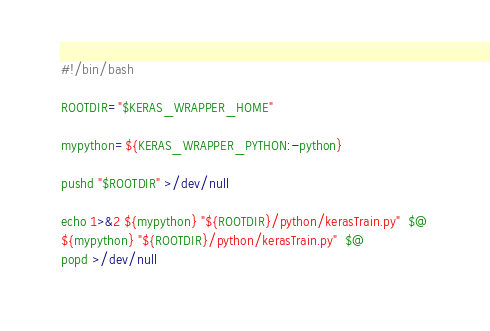Convert code to text. <code><loc_0><loc_0><loc_500><loc_500><_Bash_>#!/bin/bash

ROOTDIR="$KERAS_WRAPPER_HOME"

mypython=${KERAS_WRAPPER_PYTHON:-python}

pushd "$ROOTDIR" >/dev/null

echo 1>&2 ${mypython} "${ROOTDIR}/python/kerasTrain.py"  $@
${mypython} "${ROOTDIR}/python/kerasTrain.py"  $@
popd >/dev/null
</code> 